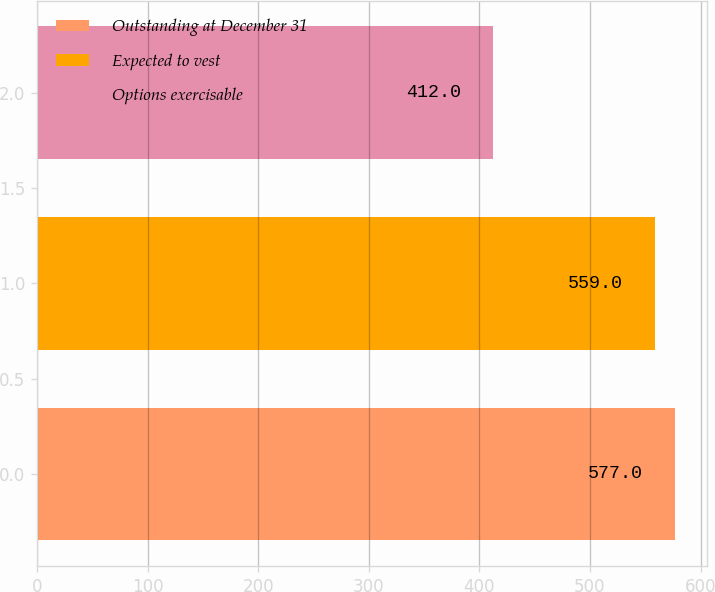Convert chart. <chart><loc_0><loc_0><loc_500><loc_500><bar_chart><fcel>Outstanding at December 31<fcel>Expected to vest<fcel>Options exercisable<nl><fcel>577<fcel>559<fcel>412<nl></chart> 